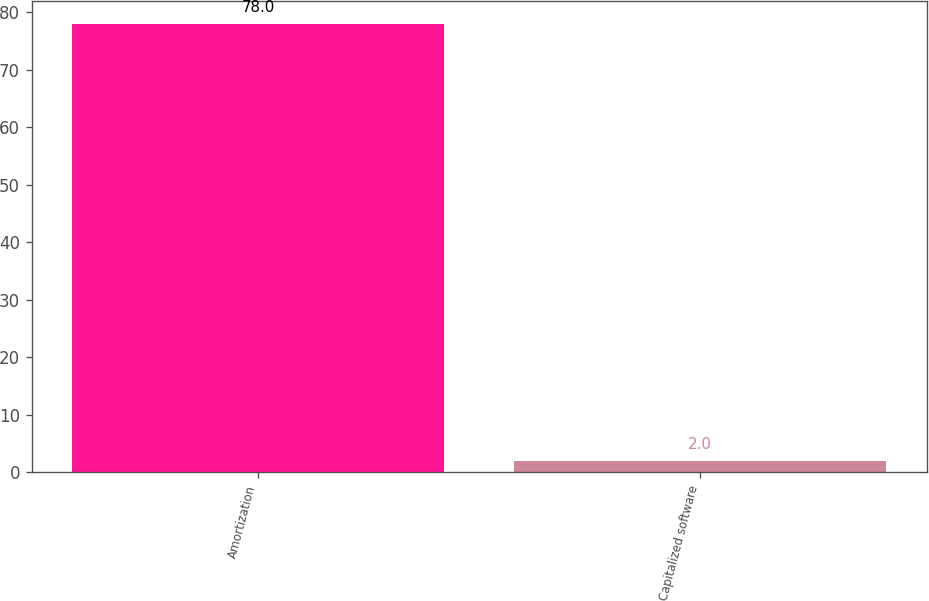Convert chart. <chart><loc_0><loc_0><loc_500><loc_500><bar_chart><fcel>Amortization<fcel>Capitalized software<nl><fcel>78<fcel>2<nl></chart> 